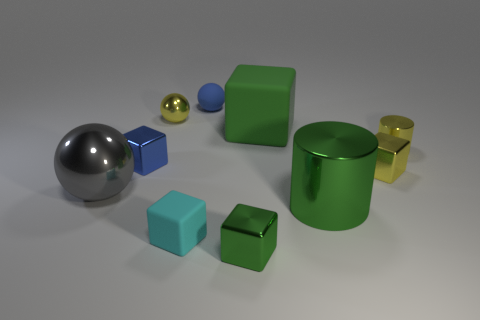Subtract all small balls. How many balls are left? 1 Subtract all blue spheres. How many spheres are left? 2 Subtract 4 blocks. How many blocks are left? 1 Subtract all blue blocks. Subtract all big gray objects. How many objects are left? 8 Add 7 big objects. How many big objects are left? 10 Add 3 gray metallic spheres. How many gray metallic spheres exist? 4 Subtract 0 purple balls. How many objects are left? 10 Subtract all cylinders. How many objects are left? 8 Subtract all yellow cubes. Subtract all purple balls. How many cubes are left? 4 Subtract all gray cubes. How many yellow balls are left? 1 